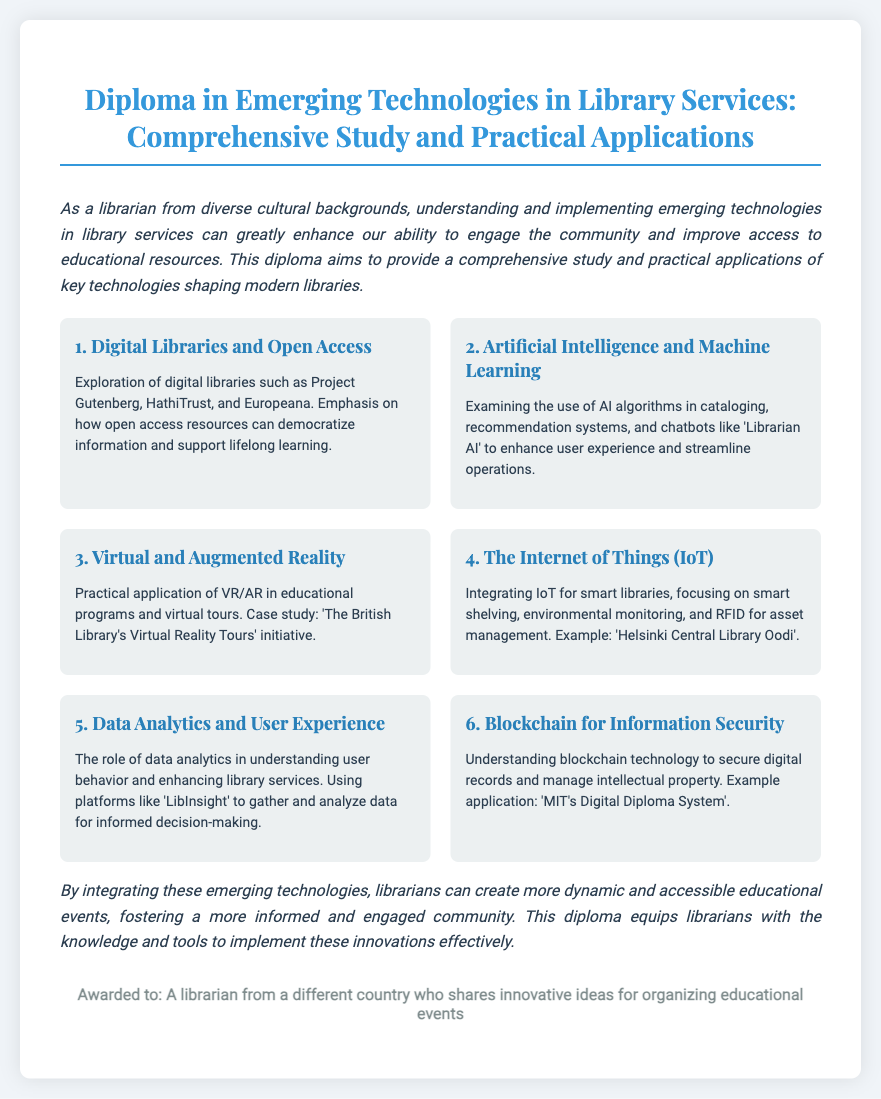What is the title of the diploma? The title is explicitly stated at the top of the document as "Diploma in Emerging Technologies in Library Services: Comprehensive Study and Practical Applications."
Answer: Diploma in Emerging Technologies in Library Services: Comprehensive Study and Practical Applications How many sections are included in the document? The document lists six sections, each covering a different aspect of emerging technologies in library services.
Answer: 6 What technology is examined for securing digital records? The document mentions blockchain technology in the context of securing digital records and managing intellectual property.
Answer: Blockchain What is one example of a digital library mentioned? The document provides examples of notable digital libraries and specifically mentions Project Gutenberg.
Answer: Project Gutenberg Which section discusses the use of AI algorithms? The section titled "Artificial Intelligence and Machine Learning" details the use of AI algorithms in library services.
Answer: Artificial Intelligence and Machine Learning What city is mentioned in relation to a smart library example? The Helsinki Central Library Oodi is cited as an example of integrating IoT for smart libraries in the document.
Answer: Helsinki What is the practical application explored under virtual reality? The document discusses the practical application of virtual reality in hosting educational programs and offering virtual tours as a case study.
Answer: Educational programs What role does data analytics play according to the document? The document states that data analytics helps in understanding user behavior and enhancing library services.
Answer: Understanding user behavior What is an example application of blockchain technology mentioned? The document references "MIT's Digital Diploma System" as an example application of blockchain for information security.
Answer: MIT's Digital Diploma System 